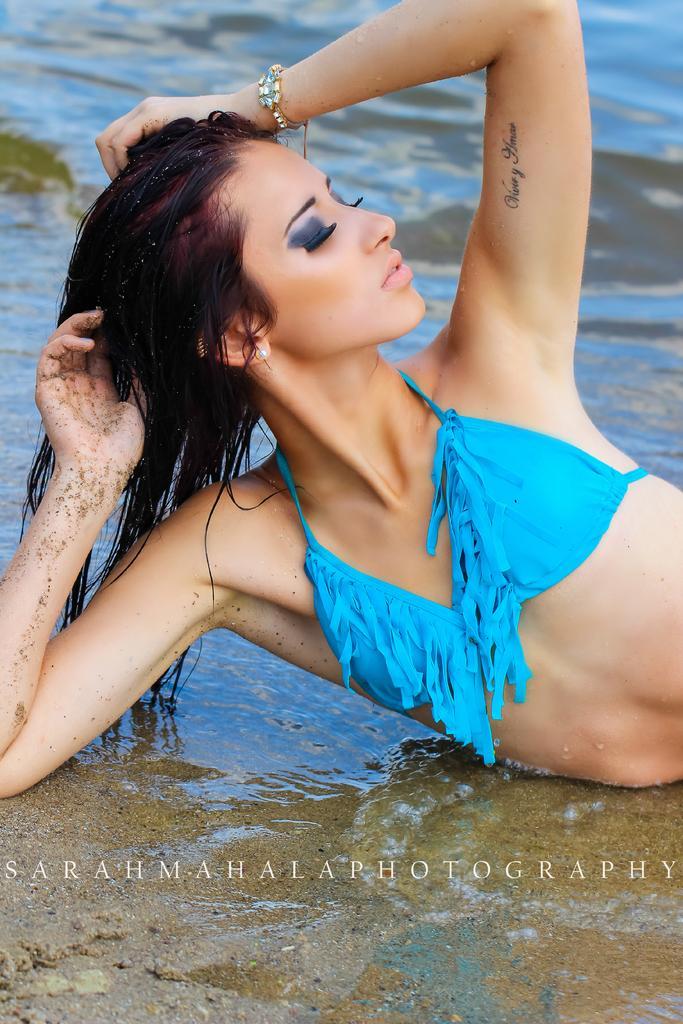In one or two sentences, can you explain what this image depicts? In this image, we can see a woman lying on the water. In the background, we can see a water. 